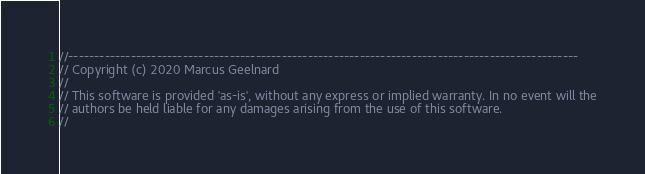Convert code to text. <code><loc_0><loc_0><loc_500><loc_500><_C++_>//--------------------------------------------------------------------------------------------------
// Copyright (c) 2020 Marcus Geelnard
//
// This software is provided 'as-is', without any express or implied warranty. In no event will the
// authors be held liable for any damages arising from the use of this software.
//</code> 